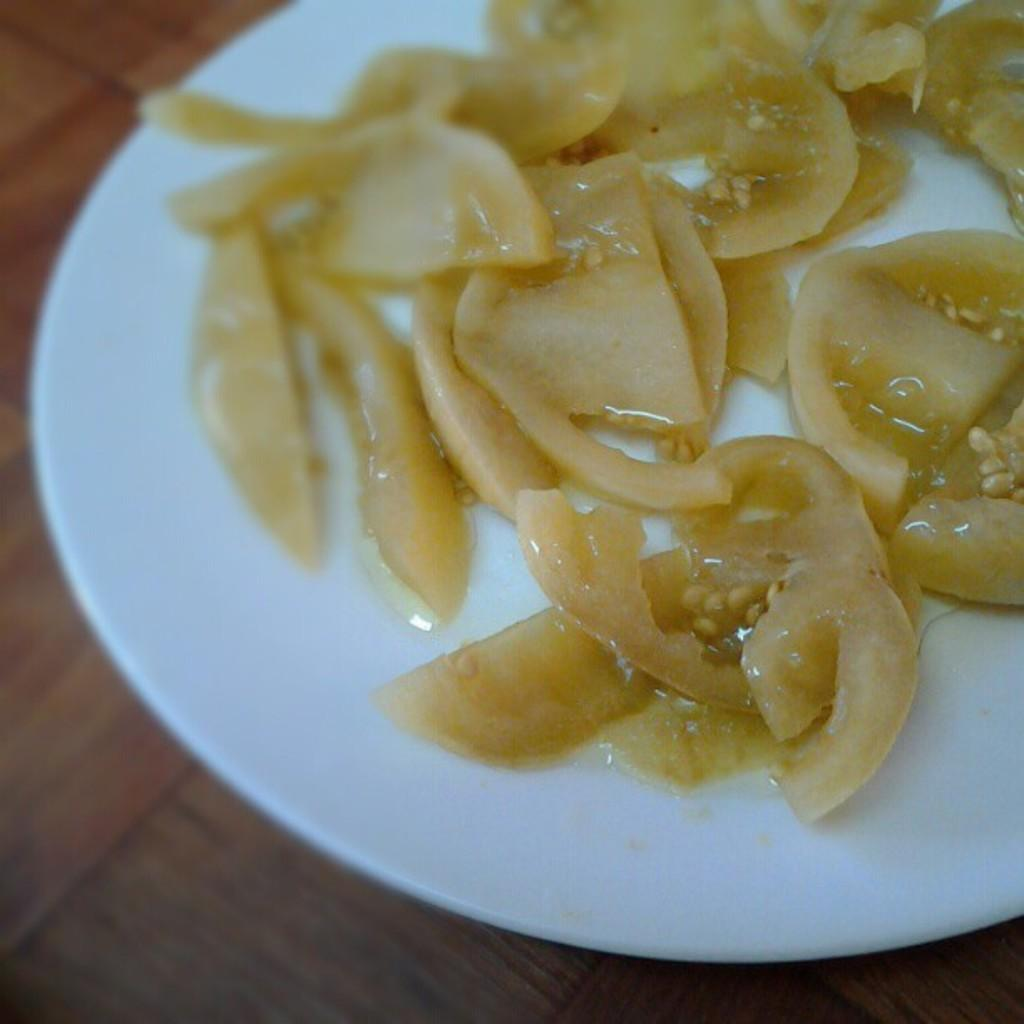What is present in the image? There is food in the image. Where is the food located? The food is placed on a surface. How many deer can be seen eating the food in the image? There are no deer present in the image; it only features food placed on a surface. 